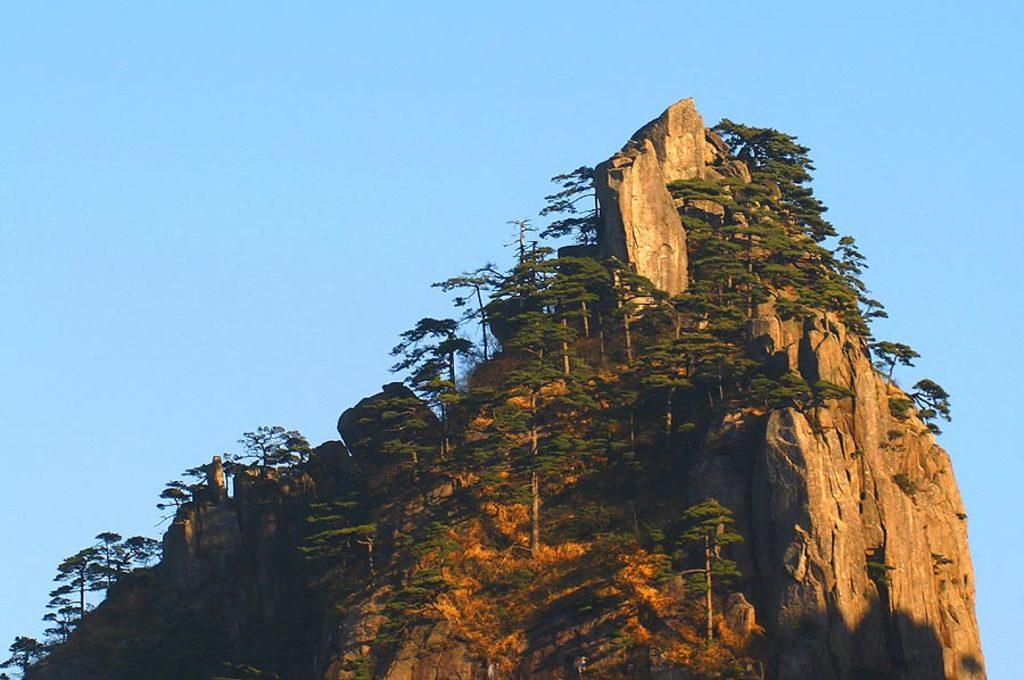What is the main geographical feature in the image? There is a mountain in the image. What type of vegetation can be seen on the mountain? Trees are present on the mountain. What time is displayed on the clocks in the image? There are no clocks present in the image, so it is not possible to determine the time. 